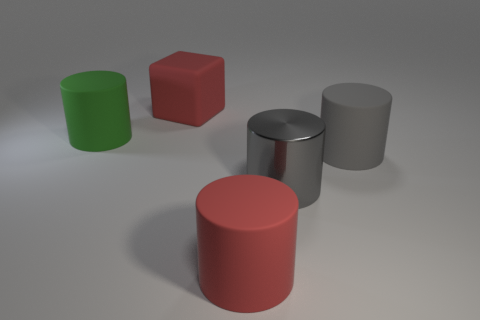Subtract all red cylinders. Subtract all brown cubes. How many cylinders are left? 3 Add 4 blue rubber things. How many objects exist? 9 Subtract all cubes. How many objects are left? 4 Add 3 red matte cubes. How many red matte cubes exist? 4 Subtract 0 blue balls. How many objects are left? 5 Subtract all big red matte cylinders. Subtract all big red rubber cubes. How many objects are left? 3 Add 4 gray cylinders. How many gray cylinders are left? 6 